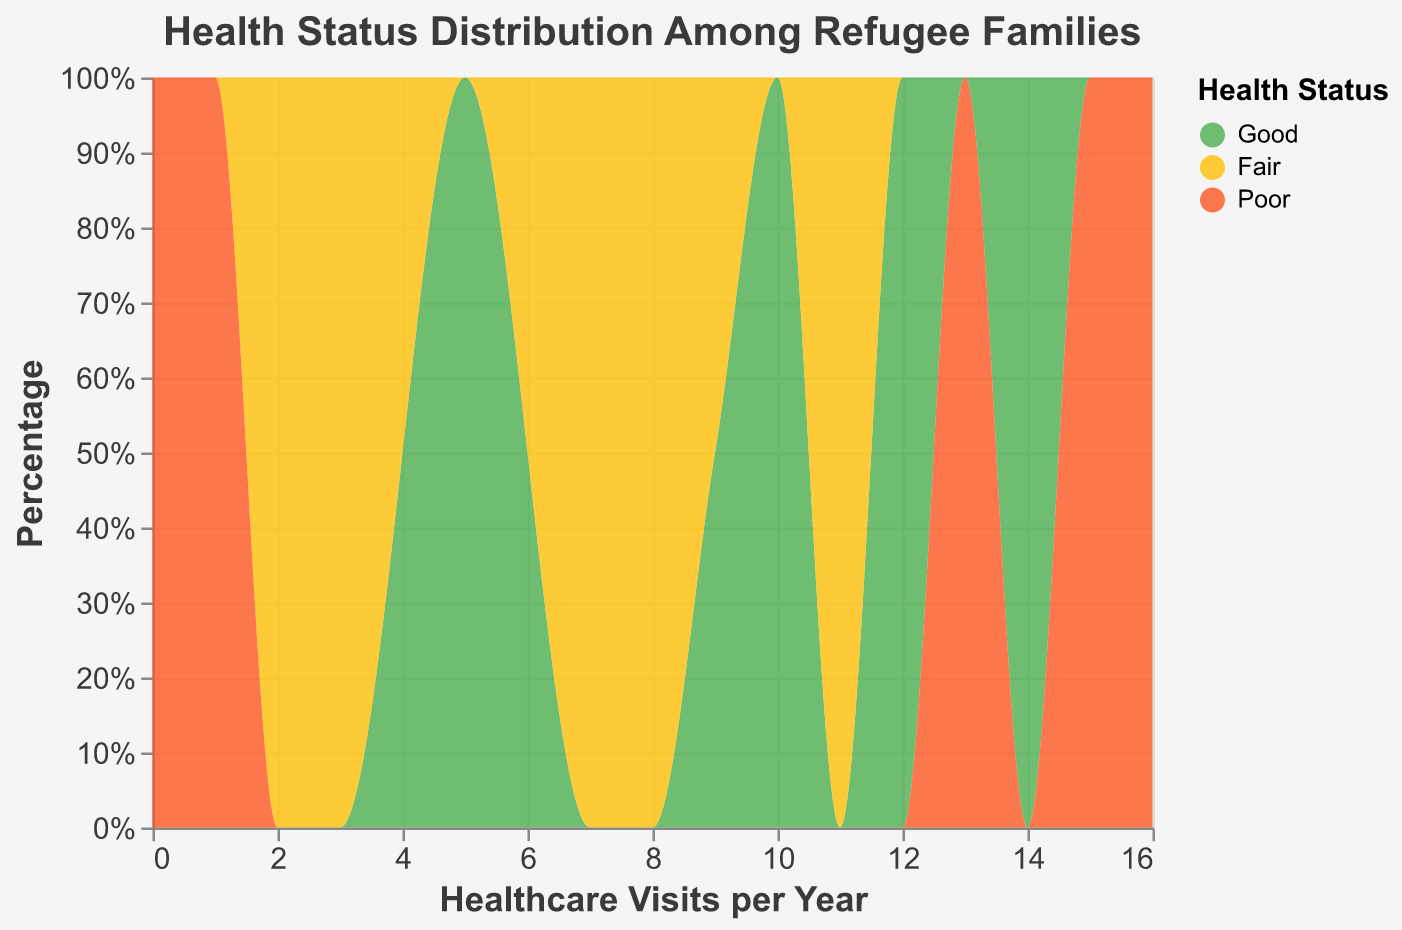What is the title of the plot? The plot's title is typically found at the top and it helps to understand what the data is about. In this case, the title indicates the focus on the distribution of health status among refugee families
Answer: Health Status Distribution Among Refugee Families What is the most common health status among refugee families with healthcare access? By looking at the density plot, we should identify the health status that appears most frequently for families who have access to healthcare
Answer: Good What is the percentage of healthcare visits per year for families with good health status compared to those with poor health status? By analyzing the normalized stacks in the density plot, one can compare the percentage contributions of different health statuses across the x-axis representing visits per year
Answer: Varies by year, generally more visits in "Good" Between 'Good' and 'Poor' health statuses, which has a higher percentage in the first quarter (i.e., fewer visits per year)? Inspect the left portion of the x-axis (0 to 5 visits per year) and compare the normalized stack heights by color
Answer: Poor What healthcare visit frequency range shows the highest density for families with fair health status? This requires identifying the peak area, in terms of visits per year, in the density plot for the color representing 'Fair' health status
Answer: Around 8-11 visits per year Does having healthcare access correlate with better health status? One way to interpret is to look at 'Good' health status distribution and see if it aligns more with families who have healthcare access
Answer: Yes, generally more families with access have 'Good' health How does healthcare access affect the range of visits per year for different health statuses? This question can be answered by visually analyzing the distribution and spread of counts across visits per year for 'Yes' and 'No' groups
Answer: Access tends toward higher visits What percentage of families with 'Poor' health status have fewer than 5 visits per year? Look at the proportion of the 'Poor' status section on the normalized y-axis within the 0-5 range on the x-axis
Answer: Significant percentage, roughly around 30-40% Do families without healthcare access ever achieve a 'Good' health status? Check the density areas filled with the color representing 'Good' health status and see if they appear for families marked 'No' for healthcare access
Answer: Yes, though less frequently 